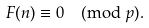<formula> <loc_0><loc_0><loc_500><loc_500>F ( n ) \equiv 0 \pmod { p } .</formula> 